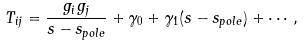Convert formula to latex. <formula><loc_0><loc_0><loc_500><loc_500>T _ { i j } = \frac { g _ { i } g _ { j } } { s - s _ { p o l e } } + \gamma _ { 0 } + \gamma _ { 1 } ( s - s _ { p o l e } ) + \cdots ,</formula> 